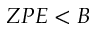<formula> <loc_0><loc_0><loc_500><loc_500>Z P E < B</formula> 